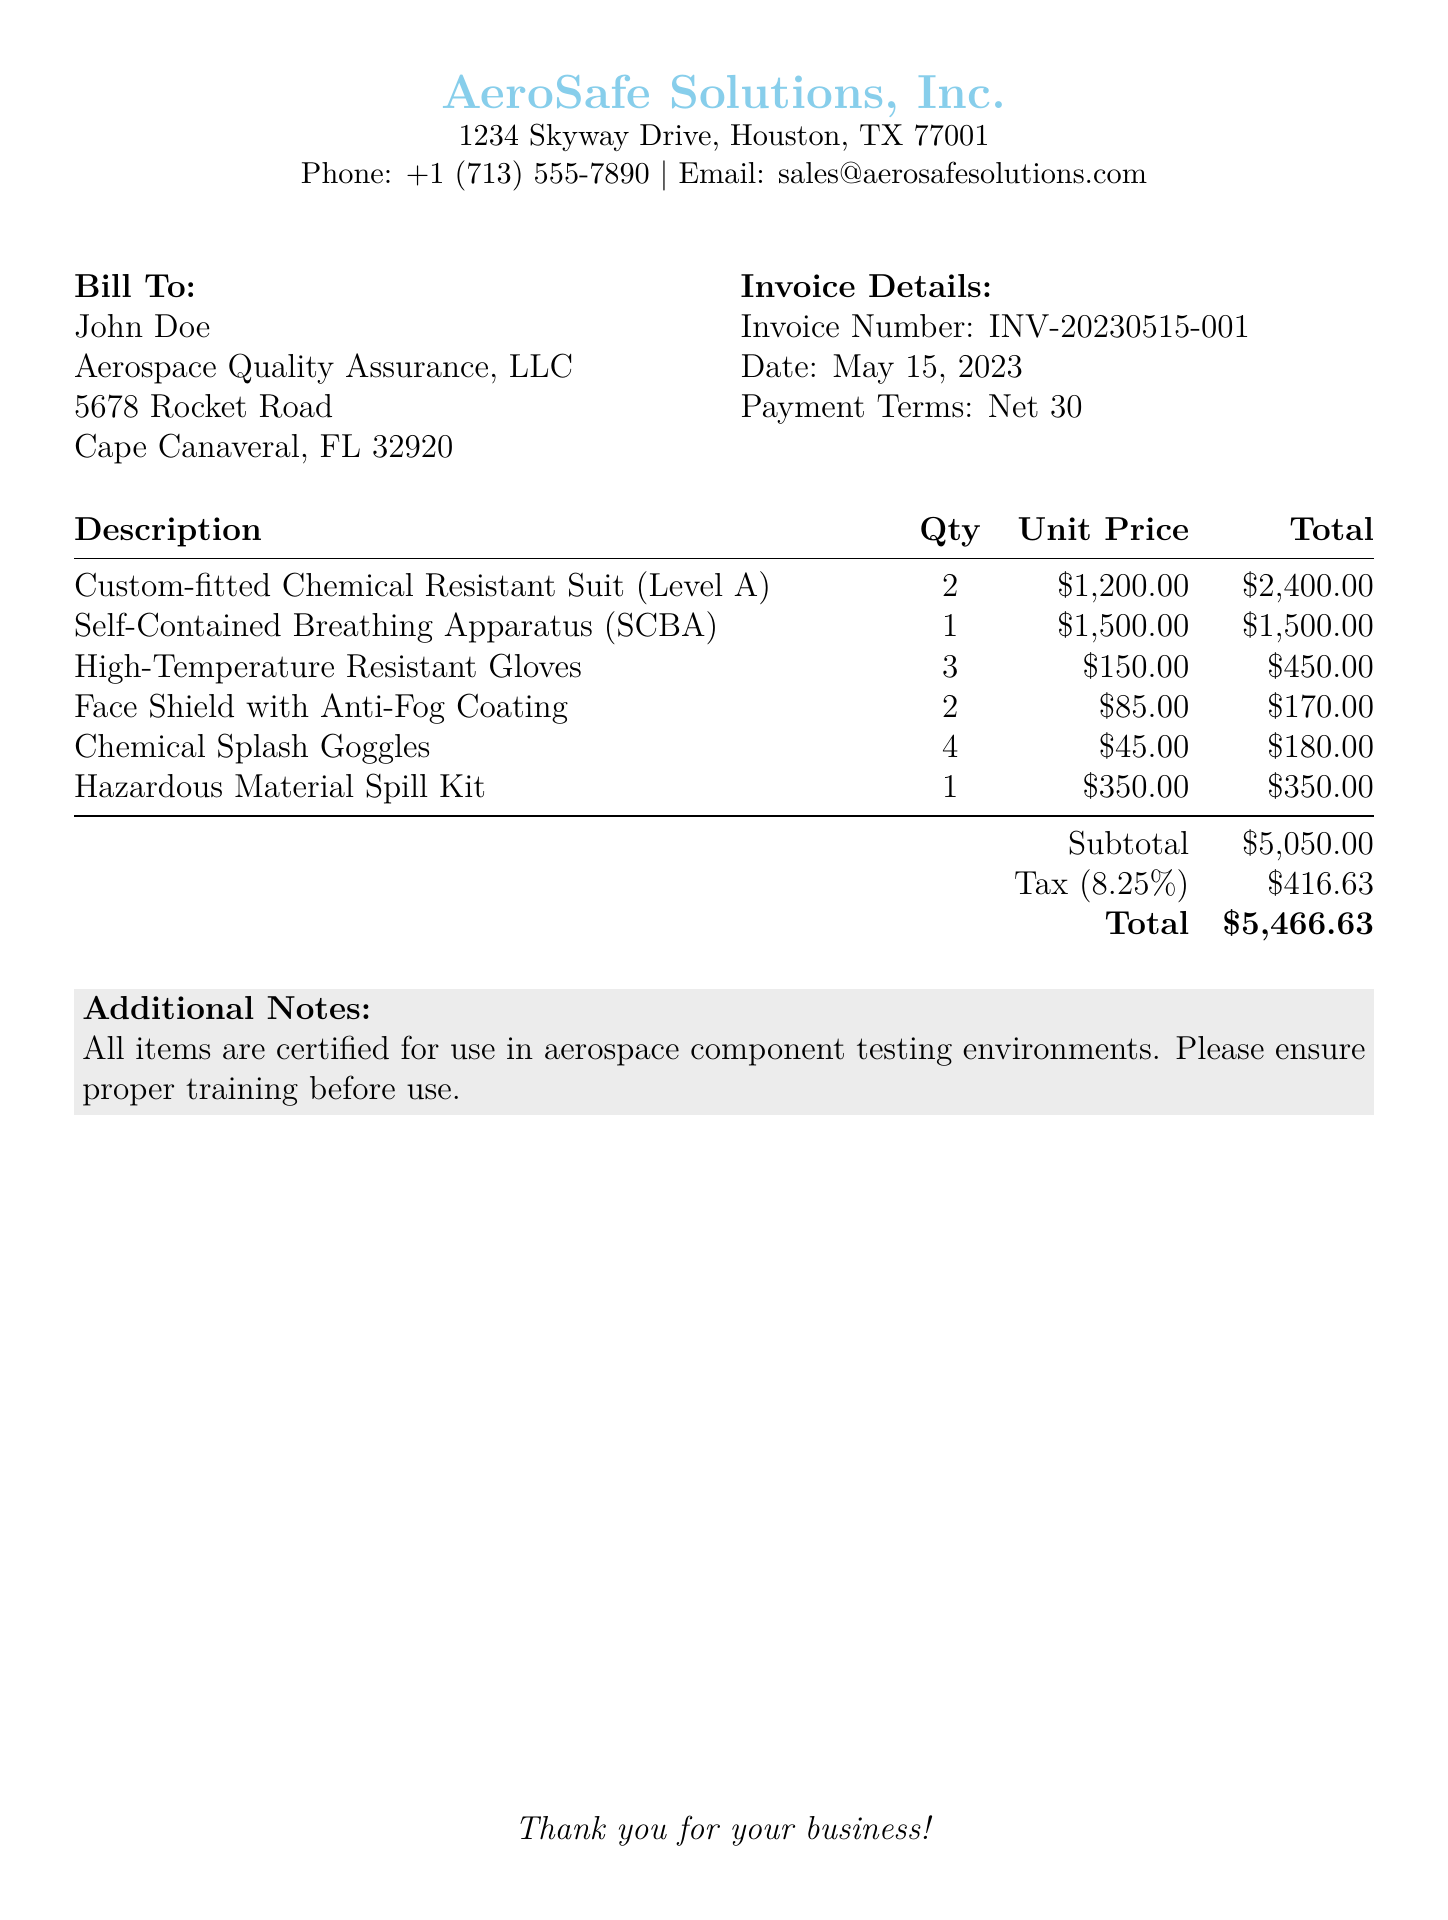what is the invoice number? The invoice number is found in the invoice details section, which identifies the specific transaction.
Answer: INV-20230515-001 what is the date of the invoice? The date is also located in the invoice details section, specifying when the invoice was issued.
Answer: May 15, 2023 how many Chemical Resistant Suits are included in the invoice? The quantity of each item can be found in the description table, showing how many of each piece of equipment is requested.
Answer: 2 what is the subtotal amount before tax? The subtotal is calculated as the sum of all item totals and is stated in the totals section of the document.
Answer: $5,050.00 what is the tax rate applied to the invoice? The tax rate is indicated in the totals section, relevant for the computation of tax on the subtotal amount.
Answer: 8.25% what is the total amount due? The total is the final amount including tax, found at the bottom of the totals section.
Answer: $5,466.63 how many Hazardous Material Spill Kits are included in the invoice? The quantity of Hazardous Material Spill Kits is listed in the description of the items on the invoice.
Answer: 1 what is the address of AeroSafe Solutions, Inc.? The address can be retrieved from the header section of the invoice, providing location details for the vendor.
Answer: 1234 Skyway Drive, Houston, TX 77001 what payment terms are specified in the invoice? The payment terms describe the timeline for payment and can be found in the invoice details section.
Answer: Net 30 